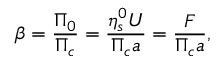Convert formula to latex. <formula><loc_0><loc_0><loc_500><loc_500>\beta = \frac { \Pi _ { 0 } } { \Pi _ { c } } = \frac { \eta _ { s } ^ { 0 } U } { \Pi _ { c } a } = \frac { F } { \Pi _ { c } a } ,</formula> 